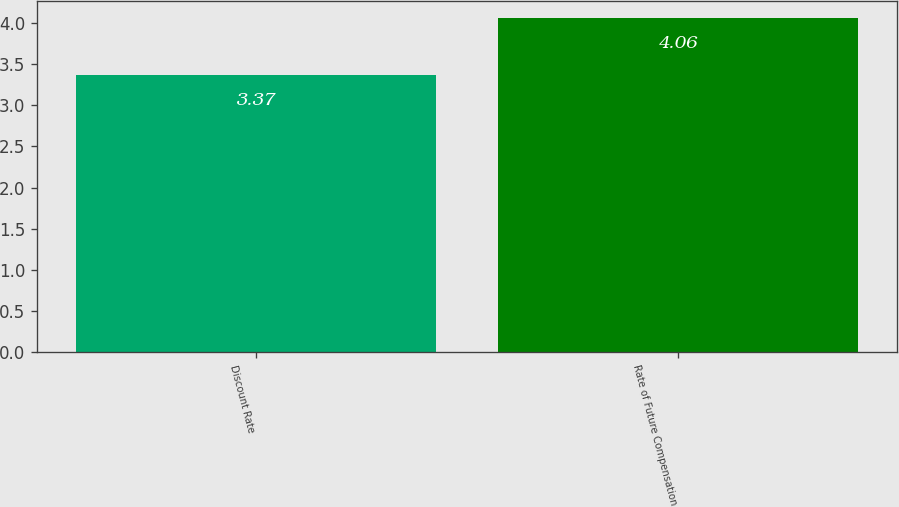<chart> <loc_0><loc_0><loc_500><loc_500><bar_chart><fcel>Discount Rate<fcel>Rate of Future Compensation<nl><fcel>3.37<fcel>4.06<nl></chart> 